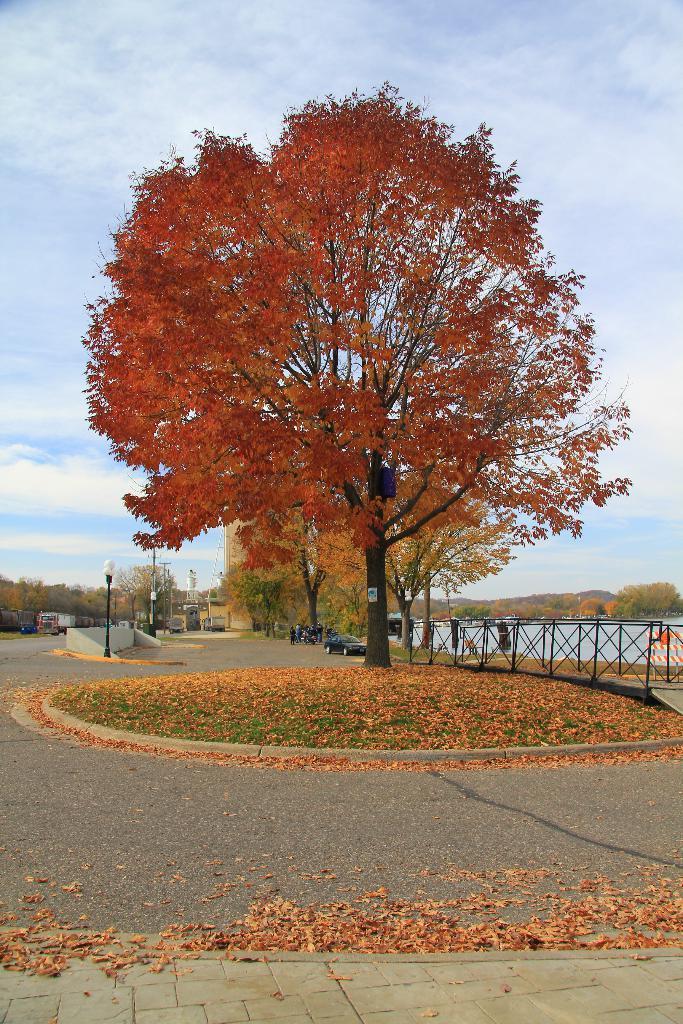In one or two sentences, can you explain what this image depicts? In this picture, we can see a tree and the path and behind the tree there are some vehicles parked on the road, fence, a pole with a light, water, hills and sky. 